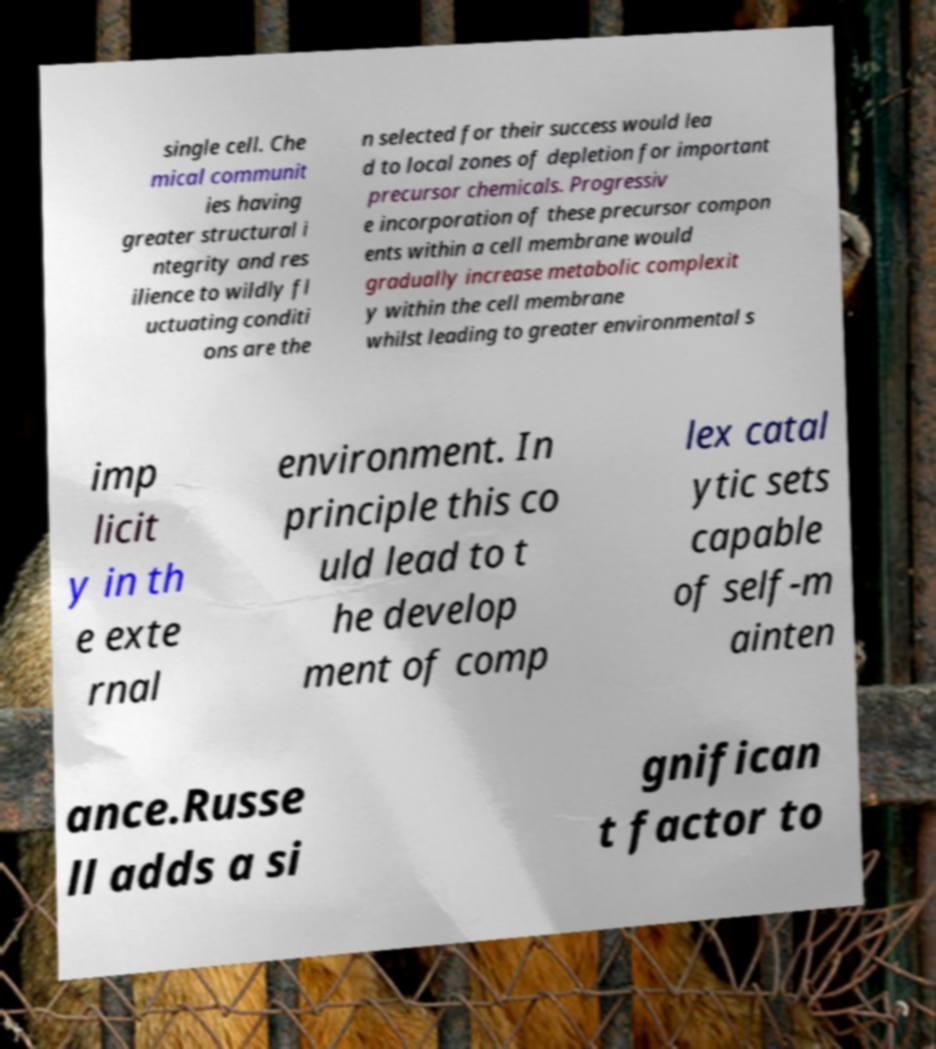Please read and relay the text visible in this image. What does it say? single cell. Che mical communit ies having greater structural i ntegrity and res ilience to wildly fl uctuating conditi ons are the n selected for their success would lea d to local zones of depletion for important precursor chemicals. Progressiv e incorporation of these precursor compon ents within a cell membrane would gradually increase metabolic complexit y within the cell membrane whilst leading to greater environmental s imp licit y in th e exte rnal environment. In principle this co uld lead to t he develop ment of comp lex catal ytic sets capable of self-m ainten ance.Russe ll adds a si gnifican t factor to 